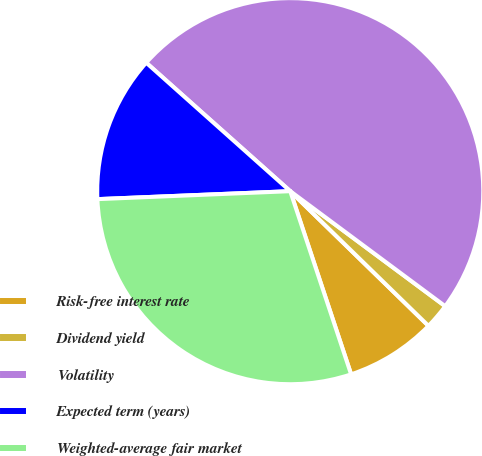<chart> <loc_0><loc_0><loc_500><loc_500><pie_chart><fcel>Risk-free interest rate<fcel>Dividend yield<fcel>Volatility<fcel>Expected term (years)<fcel>Weighted-average fair market<nl><fcel>7.6%<fcel>2.13%<fcel>48.57%<fcel>12.25%<fcel>29.45%<nl></chart> 